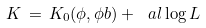Convert formula to latex. <formula><loc_0><loc_0><loc_500><loc_500>K \, = \, K _ { 0 } ( \phi , \phi b ) + \ a l \log L</formula> 